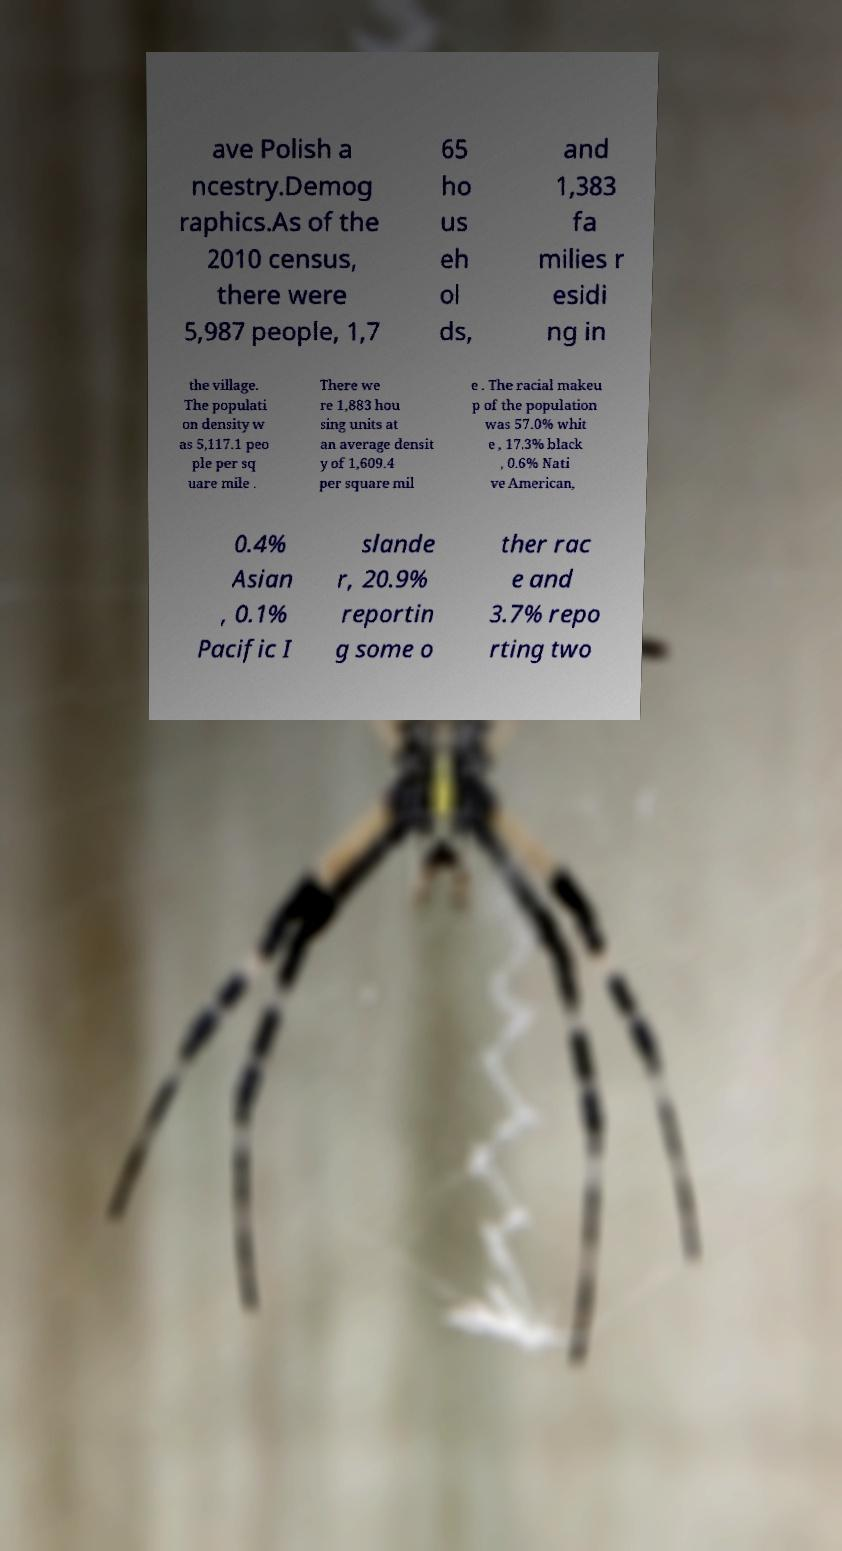Can you accurately transcribe the text from the provided image for me? ave Polish a ncestry.Demog raphics.As of the 2010 census, there were 5,987 people, 1,7 65 ho us eh ol ds, and 1,383 fa milies r esidi ng in the village. The populati on density w as 5,117.1 peo ple per sq uare mile . There we re 1,883 hou sing units at an average densit y of 1,609.4 per square mil e . The racial makeu p of the population was 57.0% whit e , 17.3% black , 0.6% Nati ve American, 0.4% Asian , 0.1% Pacific I slande r, 20.9% reportin g some o ther rac e and 3.7% repo rting two 